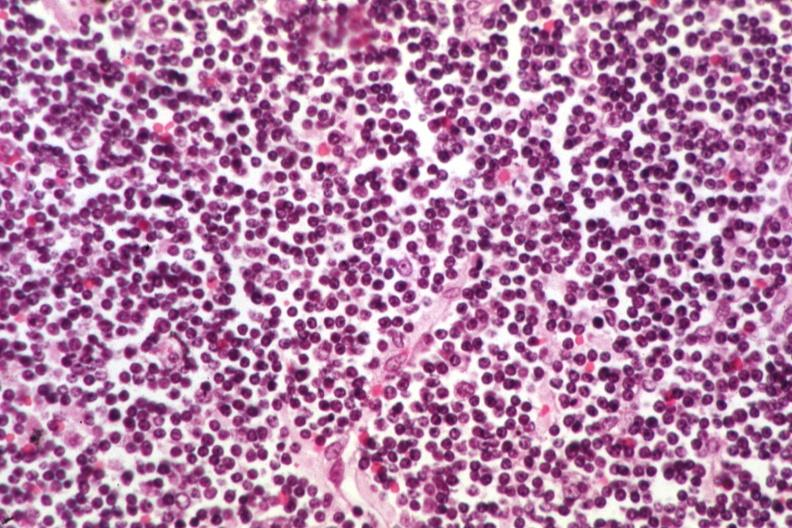what is present?
Answer the question using a single word or phrase. Lymph node 